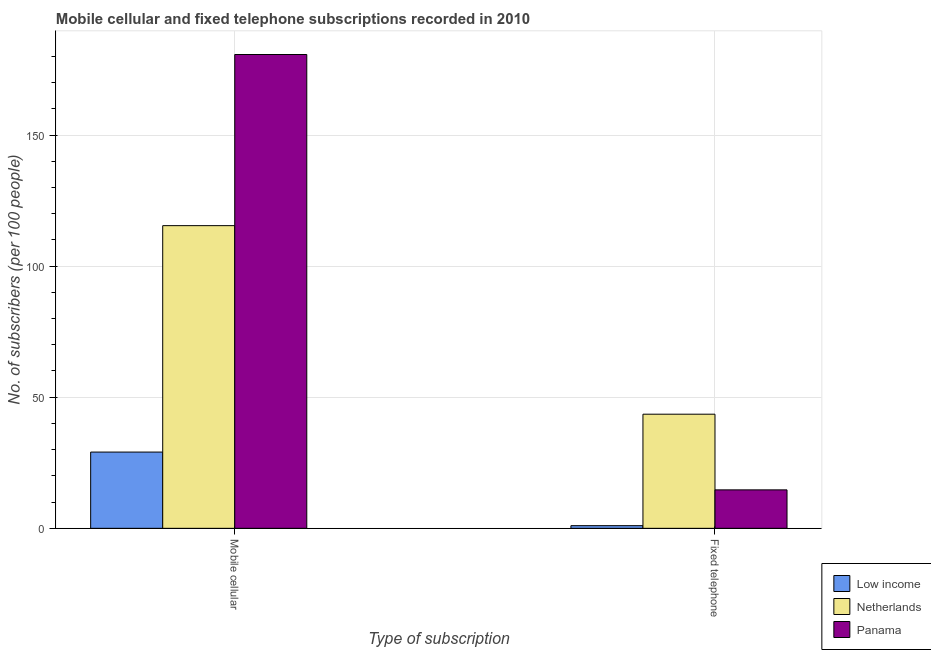How many different coloured bars are there?
Provide a succinct answer. 3. How many groups of bars are there?
Provide a short and direct response. 2. Are the number of bars per tick equal to the number of legend labels?
Your response must be concise. Yes. How many bars are there on the 1st tick from the left?
Offer a very short reply. 3. What is the label of the 1st group of bars from the left?
Provide a succinct answer. Mobile cellular. What is the number of fixed telephone subscribers in Low income?
Ensure brevity in your answer.  1.01. Across all countries, what is the maximum number of fixed telephone subscribers?
Keep it short and to the point. 43.53. Across all countries, what is the minimum number of fixed telephone subscribers?
Make the answer very short. 1.01. In which country was the number of mobile cellular subscribers maximum?
Your answer should be compact. Panama. In which country was the number of mobile cellular subscribers minimum?
Provide a succinct answer. Low income. What is the total number of fixed telephone subscribers in the graph?
Give a very brief answer. 59.2. What is the difference between the number of mobile cellular subscribers in Netherlands and that in Panama?
Ensure brevity in your answer.  -65.27. What is the difference between the number of mobile cellular subscribers in Low income and the number of fixed telephone subscribers in Netherlands?
Give a very brief answer. -14.45. What is the average number of mobile cellular subscribers per country?
Make the answer very short. 108.4. What is the difference between the number of fixed telephone subscribers and number of mobile cellular subscribers in Low income?
Offer a very short reply. -28.07. What is the ratio of the number of fixed telephone subscribers in Low income to that in Netherlands?
Ensure brevity in your answer.  0.02. What does the 3rd bar from the left in Mobile cellular represents?
Provide a succinct answer. Panama. Are all the bars in the graph horizontal?
Provide a succinct answer. No. Does the graph contain any zero values?
Provide a succinct answer. No. Where does the legend appear in the graph?
Provide a short and direct response. Bottom right. How are the legend labels stacked?
Provide a short and direct response. Vertical. What is the title of the graph?
Offer a terse response. Mobile cellular and fixed telephone subscriptions recorded in 2010. What is the label or title of the X-axis?
Keep it short and to the point. Type of subscription. What is the label or title of the Y-axis?
Make the answer very short. No. of subscribers (per 100 people). What is the No. of subscribers (per 100 people) of Low income in Mobile cellular?
Your answer should be compact. 29.08. What is the No. of subscribers (per 100 people) of Netherlands in Mobile cellular?
Make the answer very short. 115.43. What is the No. of subscribers (per 100 people) of Panama in Mobile cellular?
Provide a succinct answer. 180.7. What is the No. of subscribers (per 100 people) in Low income in Fixed telephone?
Offer a terse response. 1.01. What is the No. of subscribers (per 100 people) in Netherlands in Fixed telephone?
Provide a short and direct response. 43.53. What is the No. of subscribers (per 100 people) of Panama in Fixed telephone?
Keep it short and to the point. 14.66. Across all Type of subscription, what is the maximum No. of subscribers (per 100 people) of Low income?
Ensure brevity in your answer.  29.08. Across all Type of subscription, what is the maximum No. of subscribers (per 100 people) of Netherlands?
Your answer should be very brief. 115.43. Across all Type of subscription, what is the maximum No. of subscribers (per 100 people) in Panama?
Ensure brevity in your answer.  180.7. Across all Type of subscription, what is the minimum No. of subscribers (per 100 people) in Low income?
Keep it short and to the point. 1.01. Across all Type of subscription, what is the minimum No. of subscribers (per 100 people) of Netherlands?
Your answer should be compact. 43.53. Across all Type of subscription, what is the minimum No. of subscribers (per 100 people) in Panama?
Offer a very short reply. 14.66. What is the total No. of subscribers (per 100 people) in Low income in the graph?
Offer a very short reply. 30.09. What is the total No. of subscribers (per 100 people) in Netherlands in the graph?
Provide a short and direct response. 158.96. What is the total No. of subscribers (per 100 people) of Panama in the graph?
Offer a terse response. 195.36. What is the difference between the No. of subscribers (per 100 people) of Low income in Mobile cellular and that in Fixed telephone?
Ensure brevity in your answer.  28.07. What is the difference between the No. of subscribers (per 100 people) in Netherlands in Mobile cellular and that in Fixed telephone?
Offer a terse response. 71.9. What is the difference between the No. of subscribers (per 100 people) in Panama in Mobile cellular and that in Fixed telephone?
Offer a very short reply. 166.04. What is the difference between the No. of subscribers (per 100 people) of Low income in Mobile cellular and the No. of subscribers (per 100 people) of Netherlands in Fixed telephone?
Your response must be concise. -14.45. What is the difference between the No. of subscribers (per 100 people) in Low income in Mobile cellular and the No. of subscribers (per 100 people) in Panama in Fixed telephone?
Provide a succinct answer. 14.42. What is the difference between the No. of subscribers (per 100 people) of Netherlands in Mobile cellular and the No. of subscribers (per 100 people) of Panama in Fixed telephone?
Give a very brief answer. 100.77. What is the average No. of subscribers (per 100 people) in Low income per Type of subscription?
Offer a very short reply. 15.04. What is the average No. of subscribers (per 100 people) in Netherlands per Type of subscription?
Make the answer very short. 79.48. What is the average No. of subscribers (per 100 people) of Panama per Type of subscription?
Your answer should be compact. 97.68. What is the difference between the No. of subscribers (per 100 people) in Low income and No. of subscribers (per 100 people) in Netherlands in Mobile cellular?
Your response must be concise. -86.35. What is the difference between the No. of subscribers (per 100 people) of Low income and No. of subscribers (per 100 people) of Panama in Mobile cellular?
Your answer should be compact. -151.62. What is the difference between the No. of subscribers (per 100 people) of Netherlands and No. of subscribers (per 100 people) of Panama in Mobile cellular?
Give a very brief answer. -65.27. What is the difference between the No. of subscribers (per 100 people) in Low income and No. of subscribers (per 100 people) in Netherlands in Fixed telephone?
Offer a very short reply. -42.52. What is the difference between the No. of subscribers (per 100 people) of Low income and No. of subscribers (per 100 people) of Panama in Fixed telephone?
Keep it short and to the point. -13.65. What is the difference between the No. of subscribers (per 100 people) in Netherlands and No. of subscribers (per 100 people) in Panama in Fixed telephone?
Your answer should be very brief. 28.86. What is the ratio of the No. of subscribers (per 100 people) in Low income in Mobile cellular to that in Fixed telephone?
Provide a succinct answer. 28.76. What is the ratio of the No. of subscribers (per 100 people) of Netherlands in Mobile cellular to that in Fixed telephone?
Offer a terse response. 2.65. What is the ratio of the No. of subscribers (per 100 people) in Panama in Mobile cellular to that in Fixed telephone?
Provide a short and direct response. 12.32. What is the difference between the highest and the second highest No. of subscribers (per 100 people) of Low income?
Keep it short and to the point. 28.07. What is the difference between the highest and the second highest No. of subscribers (per 100 people) in Netherlands?
Provide a short and direct response. 71.9. What is the difference between the highest and the second highest No. of subscribers (per 100 people) of Panama?
Offer a very short reply. 166.04. What is the difference between the highest and the lowest No. of subscribers (per 100 people) of Low income?
Offer a very short reply. 28.07. What is the difference between the highest and the lowest No. of subscribers (per 100 people) of Netherlands?
Provide a short and direct response. 71.9. What is the difference between the highest and the lowest No. of subscribers (per 100 people) in Panama?
Your answer should be very brief. 166.04. 